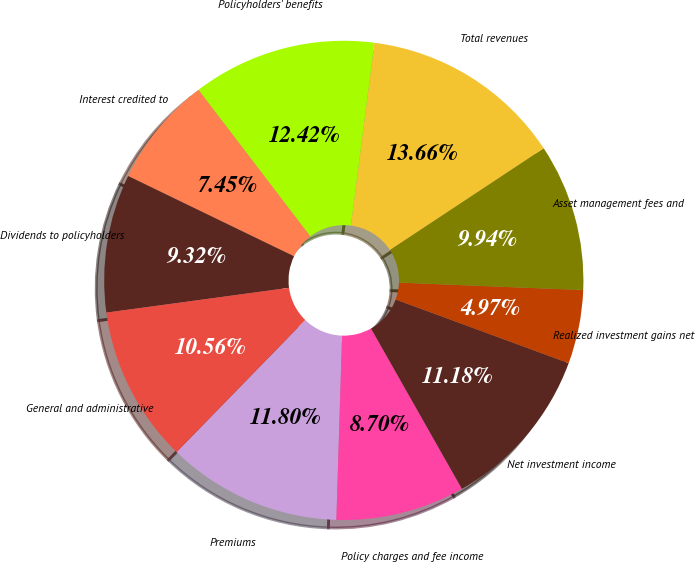Convert chart to OTSL. <chart><loc_0><loc_0><loc_500><loc_500><pie_chart><fcel>Premiums<fcel>Policy charges and fee income<fcel>Net investment income<fcel>Realized investment gains net<fcel>Asset management fees and<fcel>Total revenues<fcel>Policyholders' benefits<fcel>Interest credited to<fcel>Dividends to policyholders<fcel>General and administrative<nl><fcel>11.8%<fcel>8.7%<fcel>11.18%<fcel>4.97%<fcel>9.94%<fcel>13.66%<fcel>12.42%<fcel>7.45%<fcel>9.32%<fcel>10.56%<nl></chart> 